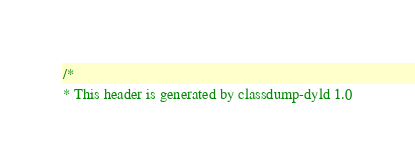Convert code to text. <code><loc_0><loc_0><loc_500><loc_500><_C_>/*
* This header is generated by classdump-dyld 1.0</code> 